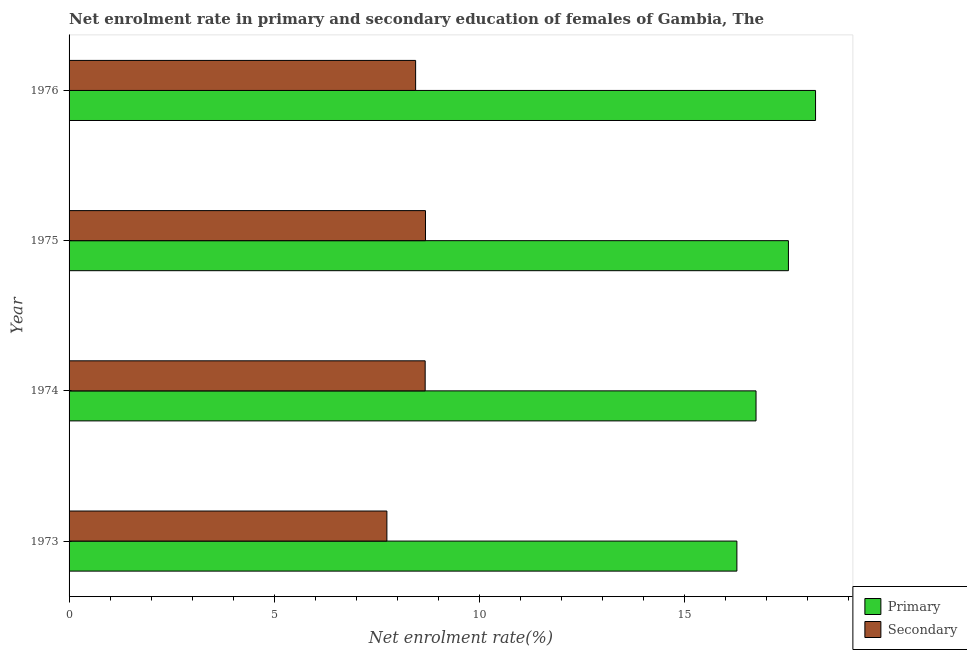Are the number of bars per tick equal to the number of legend labels?
Provide a short and direct response. Yes. Are the number of bars on each tick of the Y-axis equal?
Provide a succinct answer. Yes. How many bars are there on the 2nd tick from the top?
Ensure brevity in your answer.  2. How many bars are there on the 3rd tick from the bottom?
Keep it short and to the point. 2. What is the label of the 1st group of bars from the top?
Provide a short and direct response. 1976. In how many cases, is the number of bars for a given year not equal to the number of legend labels?
Offer a terse response. 0. What is the enrollment rate in secondary education in 1975?
Your answer should be very brief. 8.69. Across all years, what is the maximum enrollment rate in primary education?
Offer a terse response. 18.21. Across all years, what is the minimum enrollment rate in secondary education?
Provide a succinct answer. 7.75. In which year was the enrollment rate in primary education maximum?
Ensure brevity in your answer.  1976. In which year was the enrollment rate in primary education minimum?
Offer a very short reply. 1973. What is the total enrollment rate in secondary education in the graph?
Provide a succinct answer. 33.58. What is the difference between the enrollment rate in secondary education in 1974 and that in 1976?
Your answer should be very brief. 0.23. What is the difference between the enrollment rate in primary education in 1974 and the enrollment rate in secondary education in 1976?
Provide a succinct answer. 8.3. What is the average enrollment rate in secondary education per year?
Provide a succinct answer. 8.4. In the year 1974, what is the difference between the enrollment rate in primary education and enrollment rate in secondary education?
Offer a very short reply. 8.07. What is the ratio of the enrollment rate in secondary education in 1974 to that in 1976?
Provide a succinct answer. 1.03. Is the enrollment rate in secondary education in 1973 less than that in 1974?
Offer a terse response. Yes. Is the difference between the enrollment rate in secondary education in 1975 and 1976 greater than the difference between the enrollment rate in primary education in 1975 and 1976?
Your answer should be compact. Yes. What is the difference between the highest and the second highest enrollment rate in primary education?
Ensure brevity in your answer.  0.66. What is the difference between the highest and the lowest enrollment rate in secondary education?
Ensure brevity in your answer.  0.94. In how many years, is the enrollment rate in primary education greater than the average enrollment rate in primary education taken over all years?
Provide a succinct answer. 2. What does the 2nd bar from the top in 1976 represents?
Your answer should be very brief. Primary. What does the 1st bar from the bottom in 1973 represents?
Keep it short and to the point. Primary. How many bars are there?
Give a very brief answer. 8. Are all the bars in the graph horizontal?
Offer a terse response. Yes. Does the graph contain grids?
Offer a very short reply. No. How many legend labels are there?
Offer a very short reply. 2. What is the title of the graph?
Ensure brevity in your answer.  Net enrolment rate in primary and secondary education of females of Gambia, The. Does "Taxes" appear as one of the legend labels in the graph?
Ensure brevity in your answer.  No. What is the label or title of the X-axis?
Provide a short and direct response. Net enrolment rate(%). What is the label or title of the Y-axis?
Your answer should be very brief. Year. What is the Net enrolment rate(%) of Primary in 1973?
Your answer should be very brief. 16.29. What is the Net enrolment rate(%) in Secondary in 1973?
Offer a terse response. 7.75. What is the Net enrolment rate(%) in Primary in 1974?
Offer a terse response. 16.76. What is the Net enrolment rate(%) of Secondary in 1974?
Your answer should be very brief. 8.69. What is the Net enrolment rate(%) of Primary in 1975?
Your answer should be very brief. 17.55. What is the Net enrolment rate(%) of Secondary in 1975?
Give a very brief answer. 8.69. What is the Net enrolment rate(%) in Primary in 1976?
Keep it short and to the point. 18.21. What is the Net enrolment rate(%) in Secondary in 1976?
Your response must be concise. 8.45. Across all years, what is the maximum Net enrolment rate(%) of Primary?
Your answer should be compact. 18.21. Across all years, what is the maximum Net enrolment rate(%) of Secondary?
Keep it short and to the point. 8.69. Across all years, what is the minimum Net enrolment rate(%) of Primary?
Ensure brevity in your answer.  16.29. Across all years, what is the minimum Net enrolment rate(%) in Secondary?
Make the answer very short. 7.75. What is the total Net enrolment rate(%) in Primary in the graph?
Provide a short and direct response. 68.8. What is the total Net enrolment rate(%) of Secondary in the graph?
Provide a short and direct response. 33.58. What is the difference between the Net enrolment rate(%) in Primary in 1973 and that in 1974?
Your answer should be very brief. -0.47. What is the difference between the Net enrolment rate(%) of Secondary in 1973 and that in 1974?
Offer a terse response. -0.93. What is the difference between the Net enrolment rate(%) in Primary in 1973 and that in 1975?
Your answer should be very brief. -1.26. What is the difference between the Net enrolment rate(%) of Secondary in 1973 and that in 1975?
Offer a terse response. -0.94. What is the difference between the Net enrolment rate(%) in Primary in 1973 and that in 1976?
Keep it short and to the point. -1.92. What is the difference between the Net enrolment rate(%) in Secondary in 1973 and that in 1976?
Give a very brief answer. -0.7. What is the difference between the Net enrolment rate(%) of Primary in 1974 and that in 1975?
Give a very brief answer. -0.79. What is the difference between the Net enrolment rate(%) of Secondary in 1974 and that in 1975?
Offer a very short reply. -0.01. What is the difference between the Net enrolment rate(%) in Primary in 1974 and that in 1976?
Provide a short and direct response. -1.45. What is the difference between the Net enrolment rate(%) in Secondary in 1974 and that in 1976?
Offer a terse response. 0.23. What is the difference between the Net enrolment rate(%) in Primary in 1975 and that in 1976?
Your answer should be compact. -0.66. What is the difference between the Net enrolment rate(%) of Secondary in 1975 and that in 1976?
Give a very brief answer. 0.24. What is the difference between the Net enrolment rate(%) in Primary in 1973 and the Net enrolment rate(%) in Secondary in 1974?
Keep it short and to the point. 7.6. What is the difference between the Net enrolment rate(%) in Primary in 1973 and the Net enrolment rate(%) in Secondary in 1975?
Your response must be concise. 7.6. What is the difference between the Net enrolment rate(%) in Primary in 1973 and the Net enrolment rate(%) in Secondary in 1976?
Ensure brevity in your answer.  7.84. What is the difference between the Net enrolment rate(%) in Primary in 1974 and the Net enrolment rate(%) in Secondary in 1975?
Keep it short and to the point. 8.06. What is the difference between the Net enrolment rate(%) in Primary in 1974 and the Net enrolment rate(%) in Secondary in 1976?
Ensure brevity in your answer.  8.3. What is the difference between the Net enrolment rate(%) in Primary in 1975 and the Net enrolment rate(%) in Secondary in 1976?
Make the answer very short. 9.09. What is the average Net enrolment rate(%) of Primary per year?
Provide a short and direct response. 17.2. What is the average Net enrolment rate(%) in Secondary per year?
Your response must be concise. 8.4. In the year 1973, what is the difference between the Net enrolment rate(%) of Primary and Net enrolment rate(%) of Secondary?
Provide a short and direct response. 8.54. In the year 1974, what is the difference between the Net enrolment rate(%) of Primary and Net enrolment rate(%) of Secondary?
Make the answer very short. 8.07. In the year 1975, what is the difference between the Net enrolment rate(%) of Primary and Net enrolment rate(%) of Secondary?
Offer a very short reply. 8.85. In the year 1976, what is the difference between the Net enrolment rate(%) in Primary and Net enrolment rate(%) in Secondary?
Offer a terse response. 9.75. What is the ratio of the Net enrolment rate(%) of Primary in 1973 to that in 1974?
Your answer should be very brief. 0.97. What is the ratio of the Net enrolment rate(%) of Secondary in 1973 to that in 1974?
Your answer should be very brief. 0.89. What is the ratio of the Net enrolment rate(%) in Primary in 1973 to that in 1975?
Provide a succinct answer. 0.93. What is the ratio of the Net enrolment rate(%) of Secondary in 1973 to that in 1975?
Your response must be concise. 0.89. What is the ratio of the Net enrolment rate(%) in Primary in 1973 to that in 1976?
Keep it short and to the point. 0.89. What is the ratio of the Net enrolment rate(%) in Secondary in 1973 to that in 1976?
Give a very brief answer. 0.92. What is the ratio of the Net enrolment rate(%) of Primary in 1974 to that in 1975?
Provide a succinct answer. 0.95. What is the ratio of the Net enrolment rate(%) in Secondary in 1974 to that in 1975?
Your response must be concise. 1. What is the ratio of the Net enrolment rate(%) of Primary in 1974 to that in 1976?
Your answer should be very brief. 0.92. What is the ratio of the Net enrolment rate(%) in Secondary in 1974 to that in 1976?
Provide a succinct answer. 1.03. What is the ratio of the Net enrolment rate(%) in Primary in 1975 to that in 1976?
Offer a very short reply. 0.96. What is the ratio of the Net enrolment rate(%) of Secondary in 1975 to that in 1976?
Your answer should be very brief. 1.03. What is the difference between the highest and the second highest Net enrolment rate(%) of Primary?
Provide a succinct answer. 0.66. What is the difference between the highest and the second highest Net enrolment rate(%) in Secondary?
Your response must be concise. 0.01. What is the difference between the highest and the lowest Net enrolment rate(%) in Primary?
Keep it short and to the point. 1.92. What is the difference between the highest and the lowest Net enrolment rate(%) of Secondary?
Your answer should be compact. 0.94. 